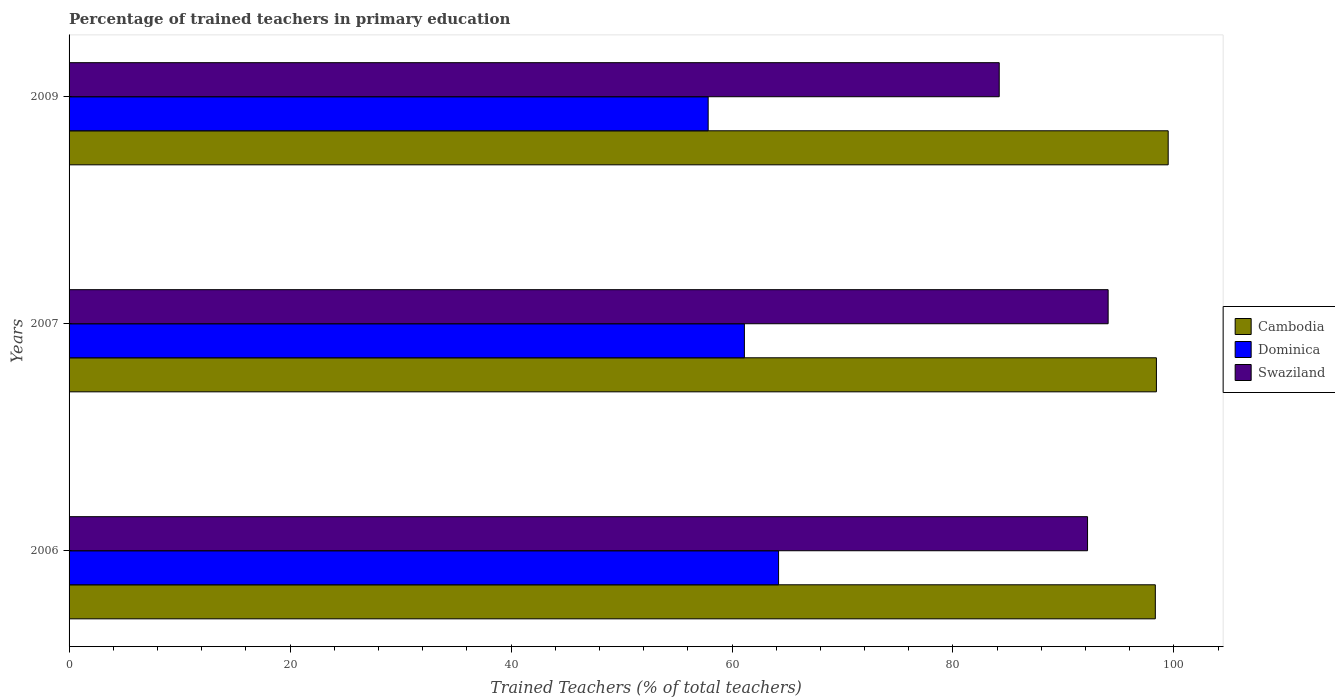How many bars are there on the 1st tick from the top?
Provide a succinct answer. 3. In how many cases, is the number of bars for a given year not equal to the number of legend labels?
Your answer should be compact. 0. What is the percentage of trained teachers in Swaziland in 2007?
Offer a very short reply. 94.04. Across all years, what is the maximum percentage of trained teachers in Cambodia?
Provide a succinct answer. 99.48. Across all years, what is the minimum percentage of trained teachers in Swaziland?
Provide a succinct answer. 84.19. In which year was the percentage of trained teachers in Cambodia maximum?
Your answer should be compact. 2009. In which year was the percentage of trained teachers in Dominica minimum?
Offer a very short reply. 2009. What is the total percentage of trained teachers in Swaziland in the graph?
Ensure brevity in your answer.  270.41. What is the difference between the percentage of trained teachers in Dominica in 2006 and that in 2007?
Ensure brevity in your answer.  3.09. What is the difference between the percentage of trained teachers in Cambodia in 2006 and the percentage of trained teachers in Dominica in 2007?
Provide a short and direct response. 37.19. What is the average percentage of trained teachers in Swaziland per year?
Offer a terse response. 90.14. In the year 2009, what is the difference between the percentage of trained teachers in Dominica and percentage of trained teachers in Cambodia?
Ensure brevity in your answer.  -41.64. In how many years, is the percentage of trained teachers in Swaziland greater than 4 %?
Your response must be concise. 3. What is the ratio of the percentage of trained teachers in Cambodia in 2006 to that in 2009?
Give a very brief answer. 0.99. Is the difference between the percentage of trained teachers in Dominica in 2006 and 2009 greater than the difference between the percentage of trained teachers in Cambodia in 2006 and 2009?
Offer a terse response. Yes. What is the difference between the highest and the second highest percentage of trained teachers in Swaziland?
Your answer should be very brief. 1.86. What is the difference between the highest and the lowest percentage of trained teachers in Cambodia?
Keep it short and to the point. 1.16. In how many years, is the percentage of trained teachers in Dominica greater than the average percentage of trained teachers in Dominica taken over all years?
Make the answer very short. 2. What does the 2nd bar from the top in 2009 represents?
Offer a very short reply. Dominica. What does the 1st bar from the bottom in 2009 represents?
Keep it short and to the point. Cambodia. Is it the case that in every year, the sum of the percentage of trained teachers in Swaziland and percentage of trained teachers in Cambodia is greater than the percentage of trained teachers in Dominica?
Your answer should be very brief. Yes. How many bars are there?
Provide a succinct answer. 9. Are all the bars in the graph horizontal?
Your answer should be compact. Yes. What is the difference between two consecutive major ticks on the X-axis?
Make the answer very short. 20. Are the values on the major ticks of X-axis written in scientific E-notation?
Offer a terse response. No. Where does the legend appear in the graph?
Offer a very short reply. Center right. What is the title of the graph?
Make the answer very short. Percentage of trained teachers in primary education. What is the label or title of the X-axis?
Provide a succinct answer. Trained Teachers (% of total teachers). What is the Trained Teachers (% of total teachers) in Cambodia in 2006?
Keep it short and to the point. 98.31. What is the Trained Teachers (% of total teachers) of Dominica in 2006?
Offer a very short reply. 64.22. What is the Trained Teachers (% of total teachers) of Swaziland in 2006?
Ensure brevity in your answer.  92.18. What is the Trained Teachers (% of total teachers) in Cambodia in 2007?
Your answer should be compact. 98.41. What is the Trained Teachers (% of total teachers) of Dominica in 2007?
Keep it short and to the point. 61.12. What is the Trained Teachers (% of total teachers) of Swaziland in 2007?
Offer a very short reply. 94.04. What is the Trained Teachers (% of total teachers) of Cambodia in 2009?
Provide a succinct answer. 99.48. What is the Trained Teachers (% of total teachers) of Dominica in 2009?
Make the answer very short. 57.84. What is the Trained Teachers (% of total teachers) of Swaziland in 2009?
Your response must be concise. 84.19. Across all years, what is the maximum Trained Teachers (% of total teachers) of Cambodia?
Offer a terse response. 99.48. Across all years, what is the maximum Trained Teachers (% of total teachers) of Dominica?
Provide a succinct answer. 64.22. Across all years, what is the maximum Trained Teachers (% of total teachers) in Swaziland?
Keep it short and to the point. 94.04. Across all years, what is the minimum Trained Teachers (% of total teachers) of Cambodia?
Ensure brevity in your answer.  98.31. Across all years, what is the minimum Trained Teachers (% of total teachers) of Dominica?
Provide a short and direct response. 57.84. Across all years, what is the minimum Trained Teachers (% of total teachers) in Swaziland?
Provide a short and direct response. 84.19. What is the total Trained Teachers (% of total teachers) of Cambodia in the graph?
Provide a short and direct response. 296.21. What is the total Trained Teachers (% of total teachers) in Dominica in the graph?
Ensure brevity in your answer.  183.18. What is the total Trained Teachers (% of total teachers) in Swaziland in the graph?
Offer a terse response. 270.41. What is the difference between the Trained Teachers (% of total teachers) in Cambodia in 2006 and that in 2007?
Ensure brevity in your answer.  -0.1. What is the difference between the Trained Teachers (% of total teachers) of Dominica in 2006 and that in 2007?
Provide a succinct answer. 3.09. What is the difference between the Trained Teachers (% of total teachers) of Swaziland in 2006 and that in 2007?
Provide a short and direct response. -1.86. What is the difference between the Trained Teachers (% of total teachers) of Cambodia in 2006 and that in 2009?
Make the answer very short. -1.16. What is the difference between the Trained Teachers (% of total teachers) in Dominica in 2006 and that in 2009?
Keep it short and to the point. 6.37. What is the difference between the Trained Teachers (% of total teachers) of Swaziland in 2006 and that in 2009?
Your answer should be compact. 7.99. What is the difference between the Trained Teachers (% of total teachers) in Cambodia in 2007 and that in 2009?
Offer a terse response. -1.07. What is the difference between the Trained Teachers (% of total teachers) in Dominica in 2007 and that in 2009?
Your response must be concise. 3.28. What is the difference between the Trained Teachers (% of total teachers) in Swaziland in 2007 and that in 2009?
Give a very brief answer. 9.86. What is the difference between the Trained Teachers (% of total teachers) of Cambodia in 2006 and the Trained Teachers (% of total teachers) of Dominica in 2007?
Ensure brevity in your answer.  37.19. What is the difference between the Trained Teachers (% of total teachers) of Cambodia in 2006 and the Trained Teachers (% of total teachers) of Swaziland in 2007?
Provide a short and direct response. 4.27. What is the difference between the Trained Teachers (% of total teachers) of Dominica in 2006 and the Trained Teachers (% of total teachers) of Swaziland in 2007?
Ensure brevity in your answer.  -29.83. What is the difference between the Trained Teachers (% of total teachers) of Cambodia in 2006 and the Trained Teachers (% of total teachers) of Dominica in 2009?
Make the answer very short. 40.47. What is the difference between the Trained Teachers (% of total teachers) in Cambodia in 2006 and the Trained Teachers (% of total teachers) in Swaziland in 2009?
Provide a succinct answer. 14.13. What is the difference between the Trained Teachers (% of total teachers) of Dominica in 2006 and the Trained Teachers (% of total teachers) of Swaziland in 2009?
Give a very brief answer. -19.97. What is the difference between the Trained Teachers (% of total teachers) in Cambodia in 2007 and the Trained Teachers (% of total teachers) in Dominica in 2009?
Keep it short and to the point. 40.57. What is the difference between the Trained Teachers (% of total teachers) of Cambodia in 2007 and the Trained Teachers (% of total teachers) of Swaziland in 2009?
Your answer should be compact. 14.23. What is the difference between the Trained Teachers (% of total teachers) in Dominica in 2007 and the Trained Teachers (% of total teachers) in Swaziland in 2009?
Give a very brief answer. -23.06. What is the average Trained Teachers (% of total teachers) in Cambodia per year?
Keep it short and to the point. 98.74. What is the average Trained Teachers (% of total teachers) of Dominica per year?
Give a very brief answer. 61.06. What is the average Trained Teachers (% of total teachers) of Swaziland per year?
Your answer should be compact. 90.14. In the year 2006, what is the difference between the Trained Teachers (% of total teachers) of Cambodia and Trained Teachers (% of total teachers) of Dominica?
Ensure brevity in your answer.  34.1. In the year 2006, what is the difference between the Trained Teachers (% of total teachers) of Cambodia and Trained Teachers (% of total teachers) of Swaziland?
Your answer should be compact. 6.13. In the year 2006, what is the difference between the Trained Teachers (% of total teachers) in Dominica and Trained Teachers (% of total teachers) in Swaziland?
Make the answer very short. -27.96. In the year 2007, what is the difference between the Trained Teachers (% of total teachers) in Cambodia and Trained Teachers (% of total teachers) in Dominica?
Your answer should be compact. 37.29. In the year 2007, what is the difference between the Trained Teachers (% of total teachers) of Cambodia and Trained Teachers (% of total teachers) of Swaziland?
Provide a short and direct response. 4.37. In the year 2007, what is the difference between the Trained Teachers (% of total teachers) in Dominica and Trained Teachers (% of total teachers) in Swaziland?
Give a very brief answer. -32.92. In the year 2009, what is the difference between the Trained Teachers (% of total teachers) in Cambodia and Trained Teachers (% of total teachers) in Dominica?
Keep it short and to the point. 41.64. In the year 2009, what is the difference between the Trained Teachers (% of total teachers) of Cambodia and Trained Teachers (% of total teachers) of Swaziland?
Make the answer very short. 15.29. In the year 2009, what is the difference between the Trained Teachers (% of total teachers) of Dominica and Trained Teachers (% of total teachers) of Swaziland?
Make the answer very short. -26.34. What is the ratio of the Trained Teachers (% of total teachers) of Cambodia in 2006 to that in 2007?
Offer a terse response. 1. What is the ratio of the Trained Teachers (% of total teachers) of Dominica in 2006 to that in 2007?
Your response must be concise. 1.05. What is the ratio of the Trained Teachers (% of total teachers) in Swaziland in 2006 to that in 2007?
Make the answer very short. 0.98. What is the ratio of the Trained Teachers (% of total teachers) in Cambodia in 2006 to that in 2009?
Make the answer very short. 0.99. What is the ratio of the Trained Teachers (% of total teachers) of Dominica in 2006 to that in 2009?
Your answer should be compact. 1.11. What is the ratio of the Trained Teachers (% of total teachers) in Swaziland in 2006 to that in 2009?
Offer a terse response. 1.09. What is the ratio of the Trained Teachers (% of total teachers) in Cambodia in 2007 to that in 2009?
Your answer should be very brief. 0.99. What is the ratio of the Trained Teachers (% of total teachers) in Dominica in 2007 to that in 2009?
Provide a succinct answer. 1.06. What is the ratio of the Trained Teachers (% of total teachers) of Swaziland in 2007 to that in 2009?
Provide a short and direct response. 1.12. What is the difference between the highest and the second highest Trained Teachers (% of total teachers) of Cambodia?
Keep it short and to the point. 1.07. What is the difference between the highest and the second highest Trained Teachers (% of total teachers) in Dominica?
Your response must be concise. 3.09. What is the difference between the highest and the second highest Trained Teachers (% of total teachers) of Swaziland?
Ensure brevity in your answer.  1.86. What is the difference between the highest and the lowest Trained Teachers (% of total teachers) of Cambodia?
Ensure brevity in your answer.  1.16. What is the difference between the highest and the lowest Trained Teachers (% of total teachers) in Dominica?
Your answer should be compact. 6.37. What is the difference between the highest and the lowest Trained Teachers (% of total teachers) in Swaziland?
Your response must be concise. 9.86. 